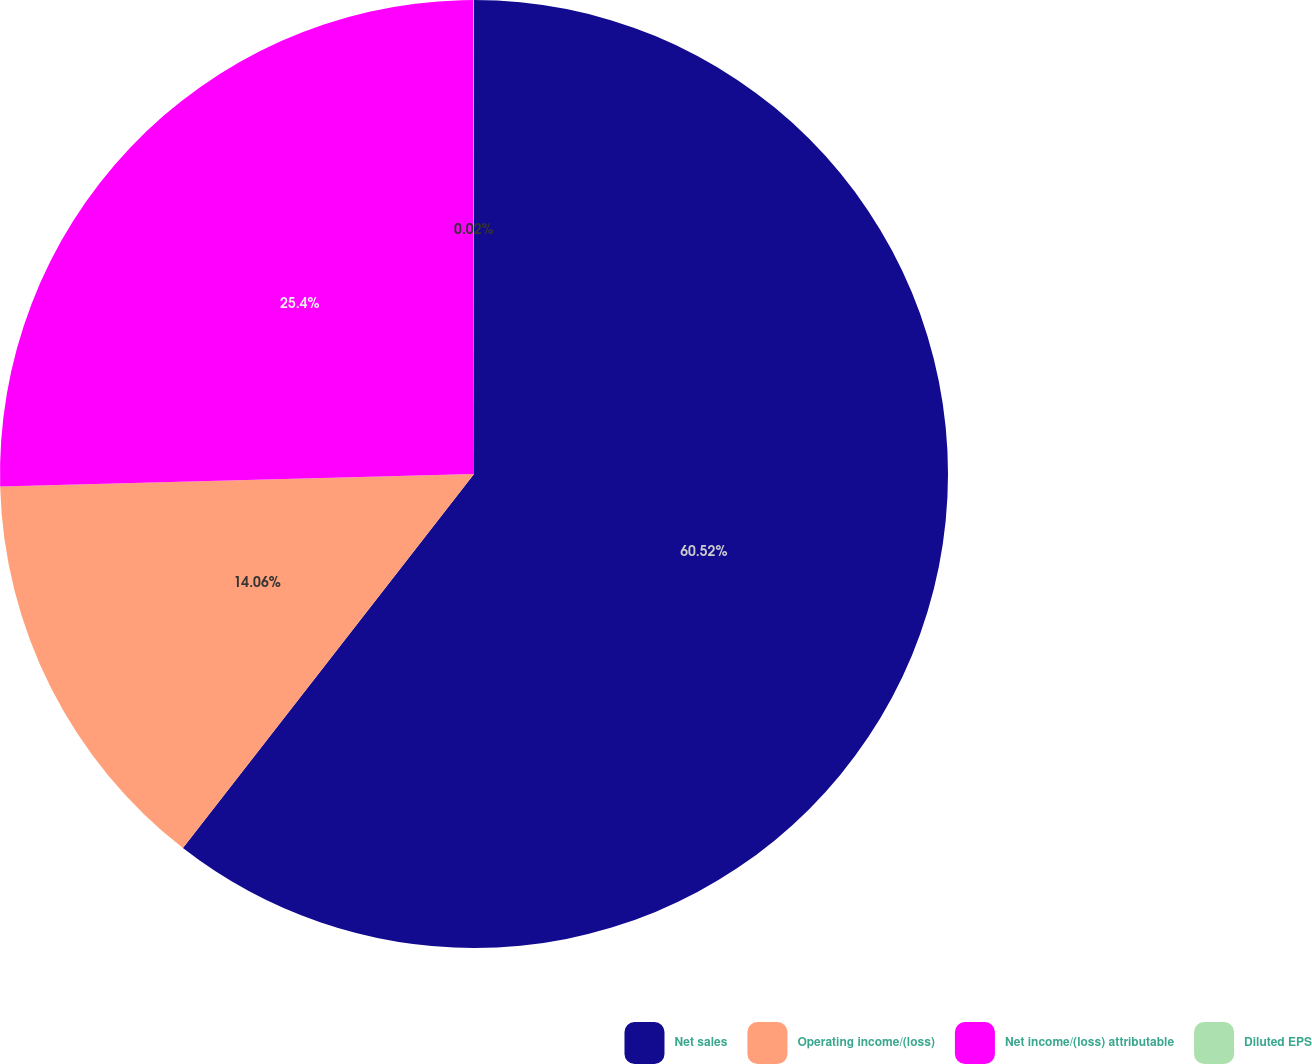<chart> <loc_0><loc_0><loc_500><loc_500><pie_chart><fcel>Net sales<fcel>Operating income/(loss)<fcel>Net income/(loss) attributable<fcel>Diluted EPS<nl><fcel>60.53%<fcel>14.06%<fcel>25.4%<fcel>0.02%<nl></chart> 